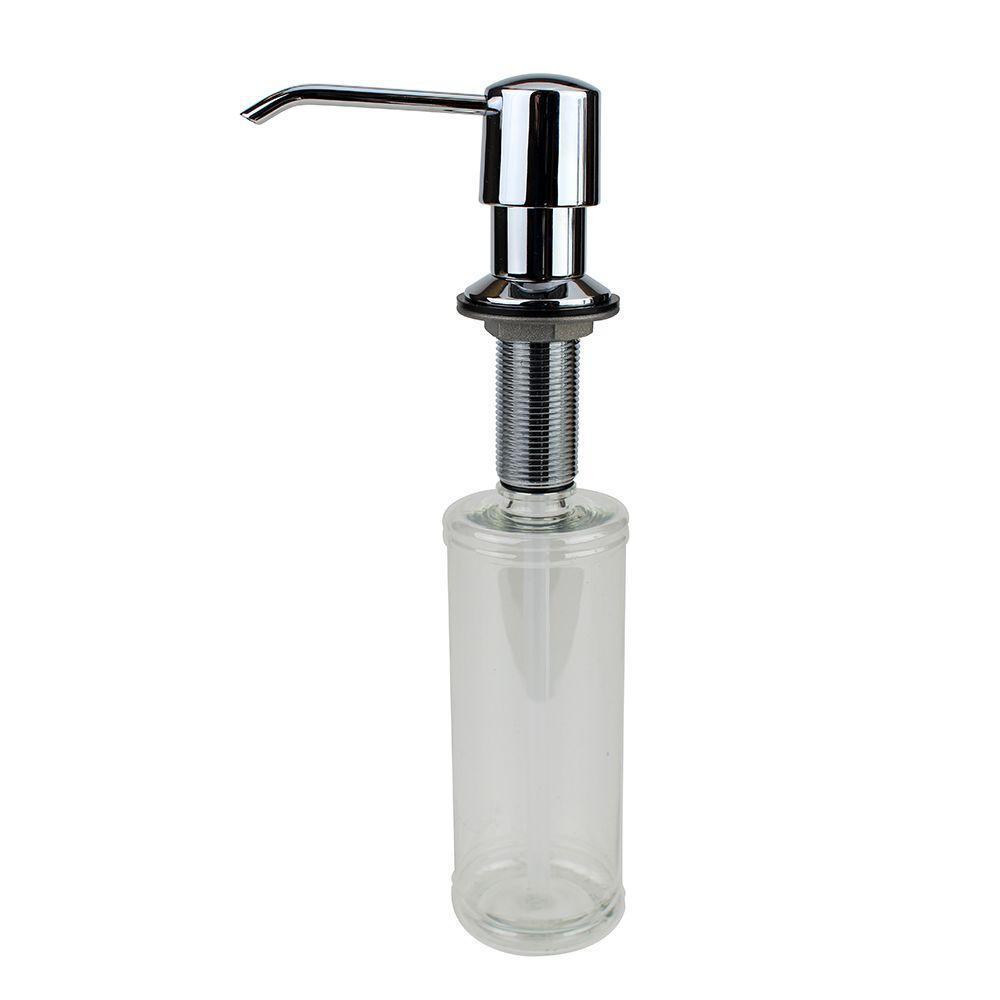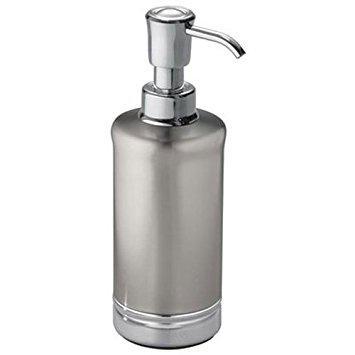The first image is the image on the left, the second image is the image on the right. Evaluate the accuracy of this statement regarding the images: "The nozzle in the left image is silver colored.". Is it true? Answer yes or no. Yes. The first image is the image on the left, the second image is the image on the right. Assess this claim about the two images: "The left and right image contains the same number of soap pumps.". Correct or not? Answer yes or no. Yes. 